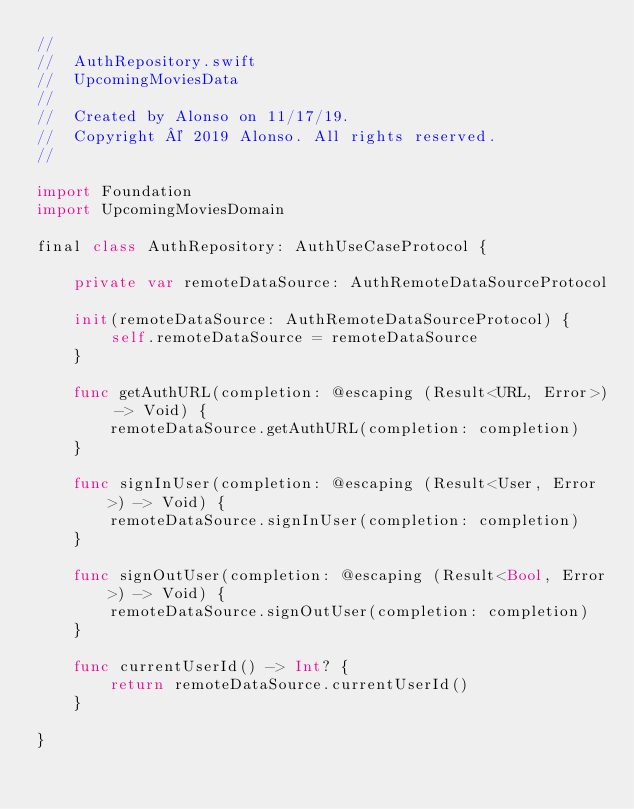Convert code to text. <code><loc_0><loc_0><loc_500><loc_500><_Swift_>//
//  AuthRepository.swift
//  UpcomingMoviesData
//
//  Created by Alonso on 11/17/19.
//  Copyright © 2019 Alonso. All rights reserved.
//

import Foundation
import UpcomingMoviesDomain

final class AuthRepository: AuthUseCaseProtocol {
    
    private var remoteDataSource: AuthRemoteDataSourceProtocol
    
    init(remoteDataSource: AuthRemoteDataSourceProtocol) {
        self.remoteDataSource = remoteDataSource
    }
    
    func getAuthURL(completion: @escaping (Result<URL, Error>) -> Void) {
        remoteDataSource.getAuthURL(completion: completion)
    }
    
    func signInUser(completion: @escaping (Result<User, Error>) -> Void) {
        remoteDataSource.signInUser(completion: completion)
    }
    
    func signOutUser(completion: @escaping (Result<Bool, Error>) -> Void) {
        remoteDataSource.signOutUser(completion: completion)
    }
    
    func currentUserId() -> Int? {
        return remoteDataSource.currentUserId()
    }
    
}
</code> 